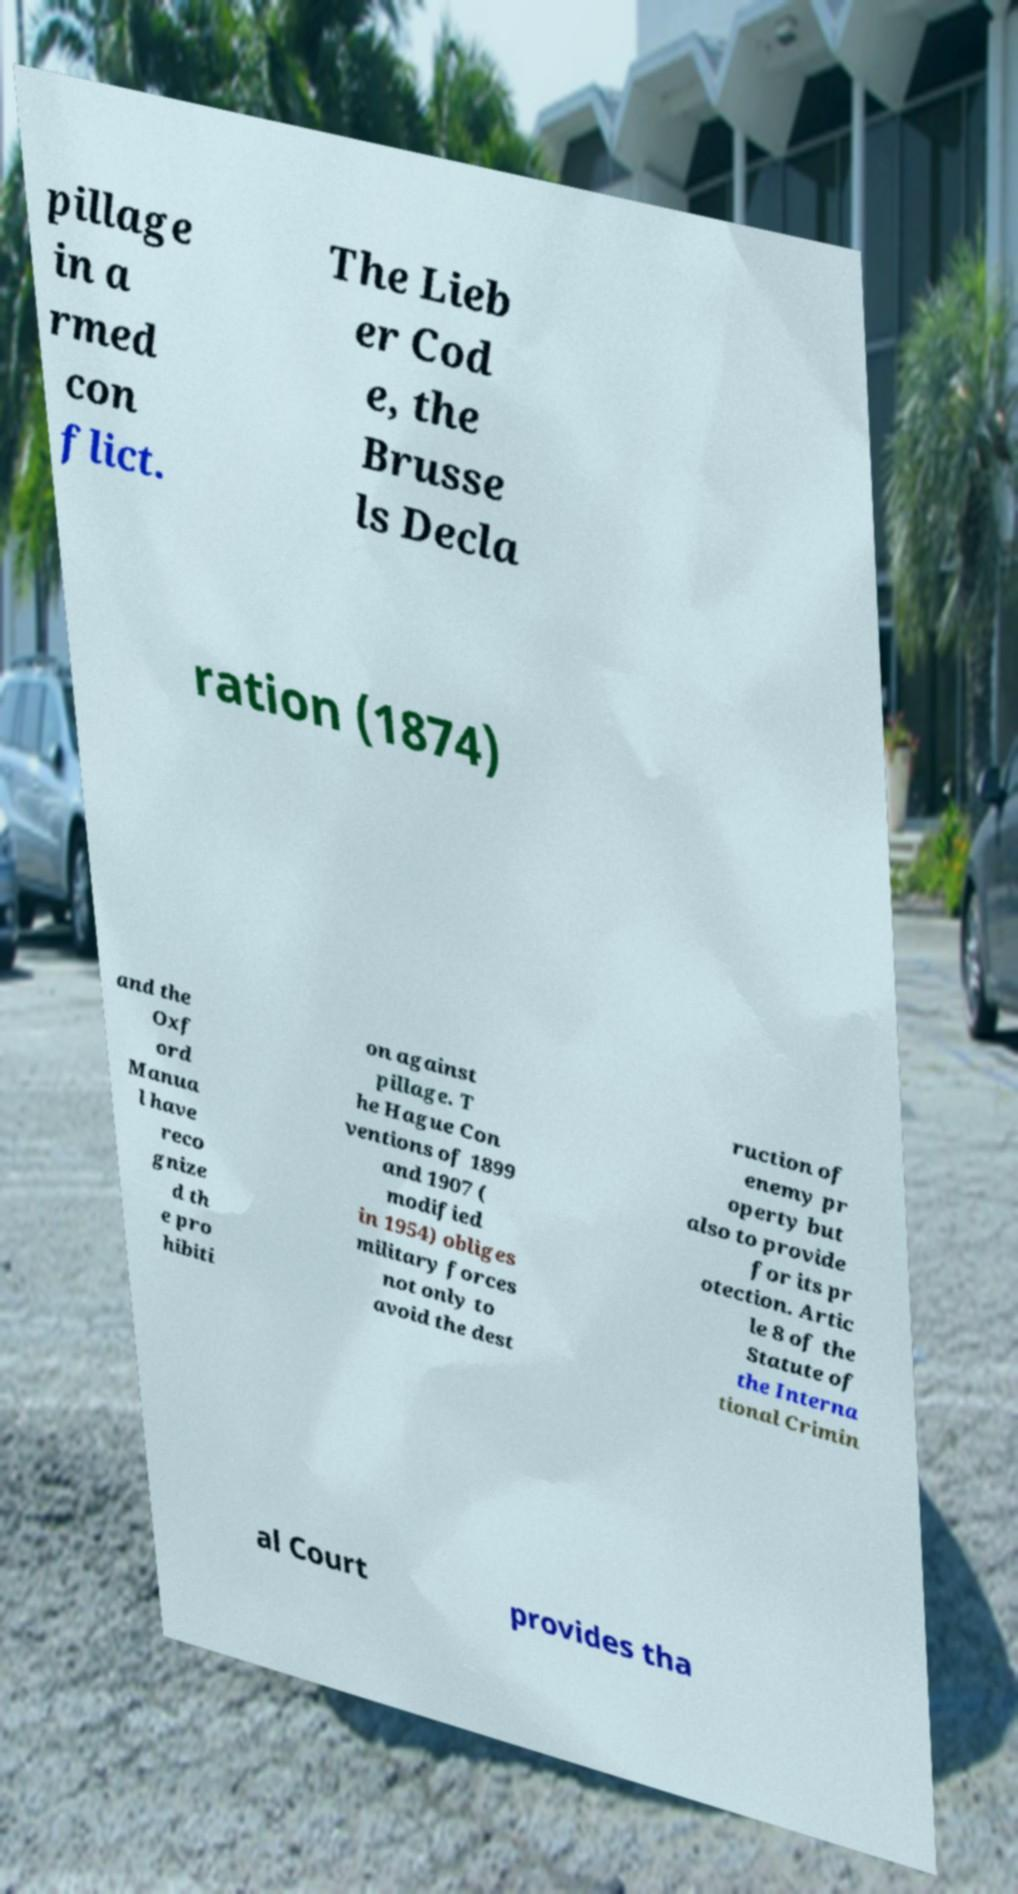Could you extract and type out the text from this image? pillage in a rmed con flict. The Lieb er Cod e, the Brusse ls Decla ration (1874) and the Oxf ord Manua l have reco gnize d th e pro hibiti on against pillage. T he Hague Con ventions of 1899 and 1907 ( modified in 1954) obliges military forces not only to avoid the dest ruction of enemy pr operty but also to provide for its pr otection. Artic le 8 of the Statute of the Interna tional Crimin al Court provides tha 